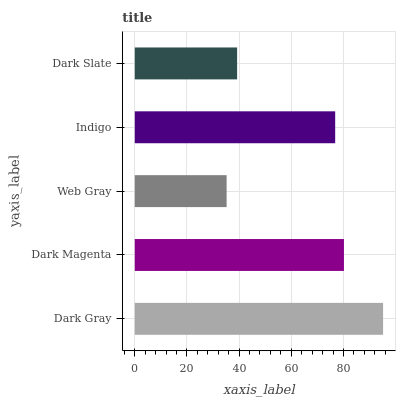Is Web Gray the minimum?
Answer yes or no. Yes. Is Dark Gray the maximum?
Answer yes or no. Yes. Is Dark Magenta the minimum?
Answer yes or no. No. Is Dark Magenta the maximum?
Answer yes or no. No. Is Dark Gray greater than Dark Magenta?
Answer yes or no. Yes. Is Dark Magenta less than Dark Gray?
Answer yes or no. Yes. Is Dark Magenta greater than Dark Gray?
Answer yes or no. No. Is Dark Gray less than Dark Magenta?
Answer yes or no. No. Is Indigo the high median?
Answer yes or no. Yes. Is Indigo the low median?
Answer yes or no. Yes. Is Dark Slate the high median?
Answer yes or no. No. Is Dark Gray the low median?
Answer yes or no. No. 